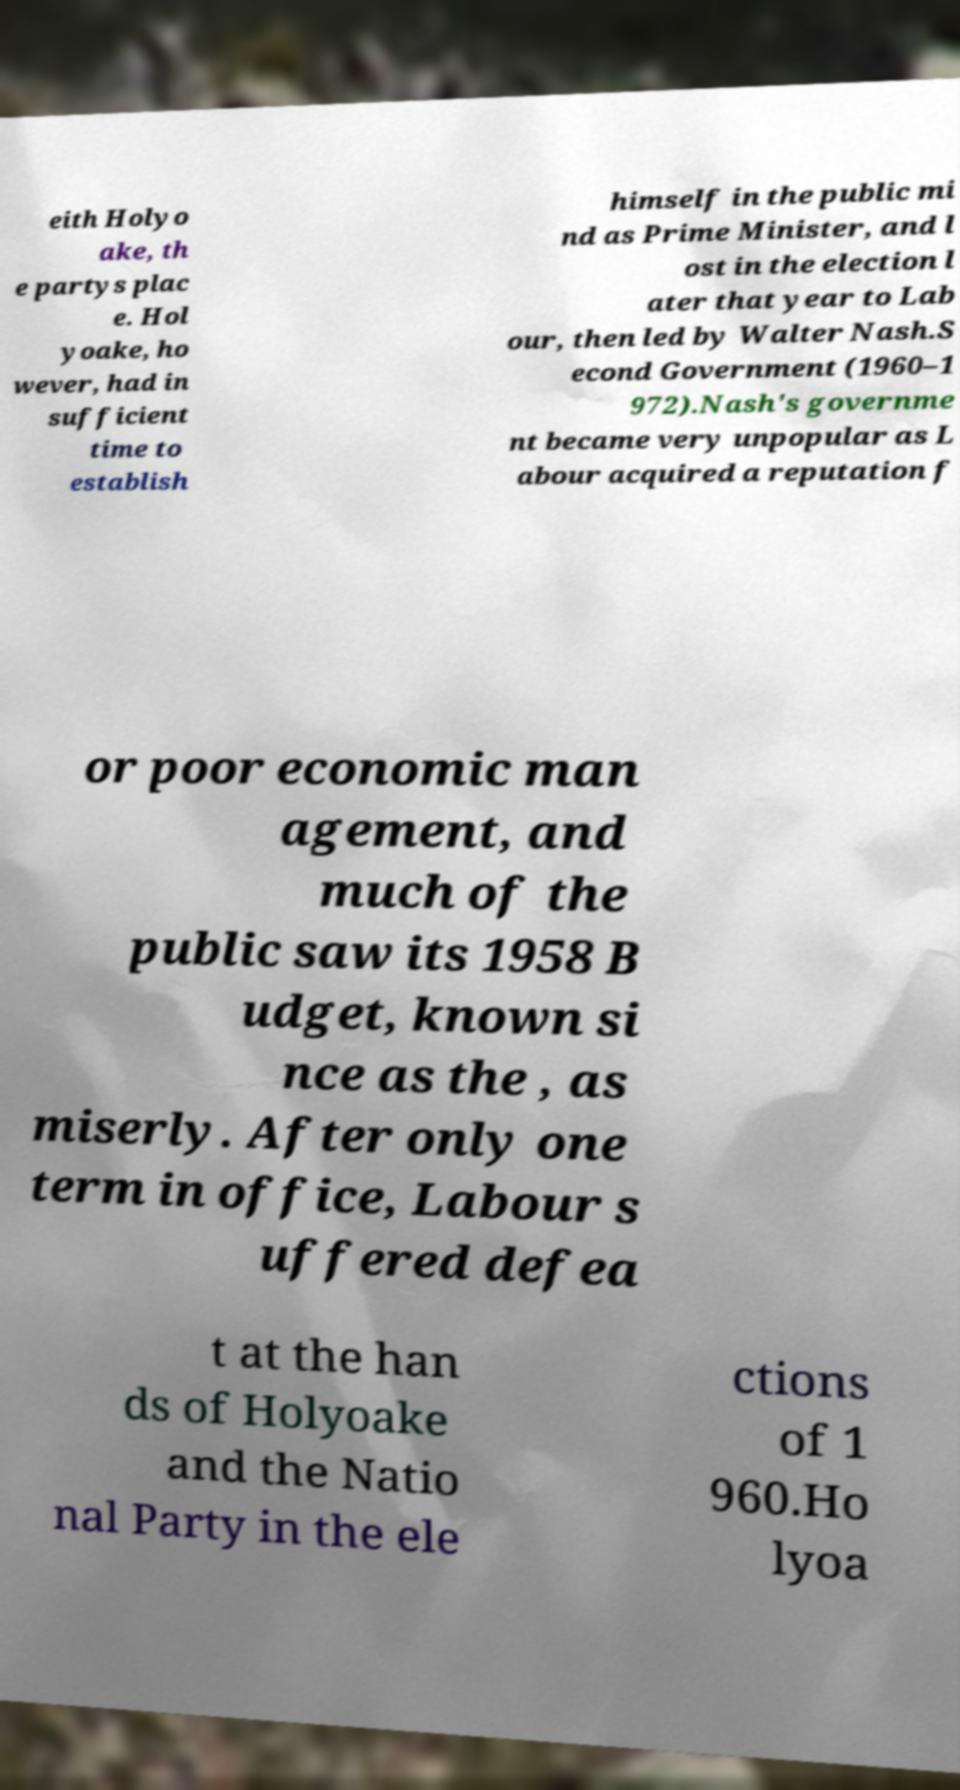What messages or text are displayed in this image? I need them in a readable, typed format. eith Holyo ake, th e partys plac e. Hol yoake, ho wever, had in sufficient time to establish himself in the public mi nd as Prime Minister, and l ost in the election l ater that year to Lab our, then led by Walter Nash.S econd Government (1960–1 972).Nash's governme nt became very unpopular as L abour acquired a reputation f or poor economic man agement, and much of the public saw its 1958 B udget, known si nce as the , as miserly. After only one term in office, Labour s uffered defea t at the han ds of Holyoake and the Natio nal Party in the ele ctions of 1 960.Ho lyoa 